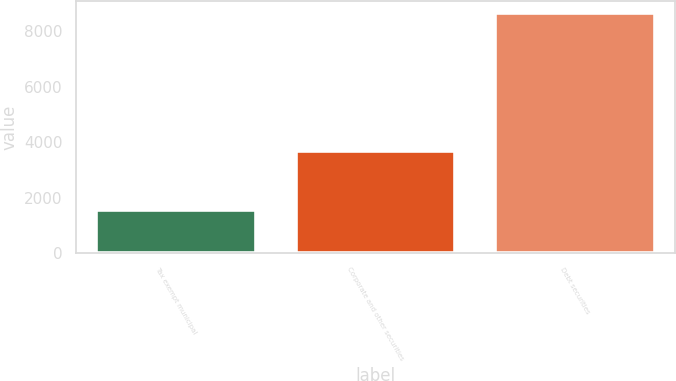<chart> <loc_0><loc_0><loc_500><loc_500><bar_chart><fcel>Tax exempt municipal<fcel>Corporate and other securities<fcel>Debt securities<nl><fcel>1566<fcel>3674<fcel>8660<nl></chart> 